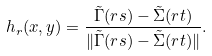<formula> <loc_0><loc_0><loc_500><loc_500>h _ { r } ( x , y ) = \frac { \tilde { \Gamma } ( r s ) - \tilde { \Sigma } ( r t ) } { \| \tilde { \Gamma } ( r s ) - \tilde { \Sigma } ( r t ) \| } .</formula> 